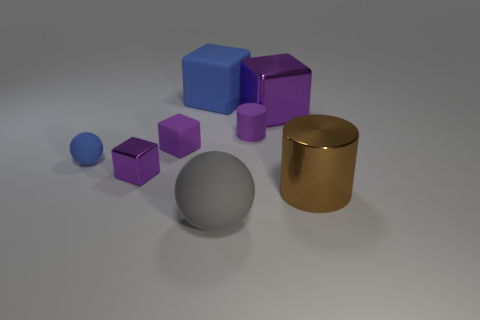Subtract all blue cylinders. How many purple cubes are left? 3 Subtract all blue cubes. Subtract all gray cylinders. How many cubes are left? 3 Add 1 yellow shiny cubes. How many objects exist? 9 Subtract all cylinders. How many objects are left? 6 Add 7 large brown metallic cylinders. How many large brown metallic cylinders exist? 8 Subtract 0 gray blocks. How many objects are left? 8 Subtract all large gray balls. Subtract all large gray things. How many objects are left? 6 Add 1 big gray objects. How many big gray objects are left? 2 